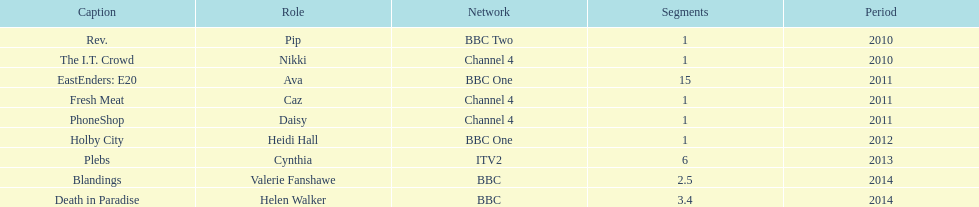What is the total number of shows sophie colguhoun appeared in? 9. 